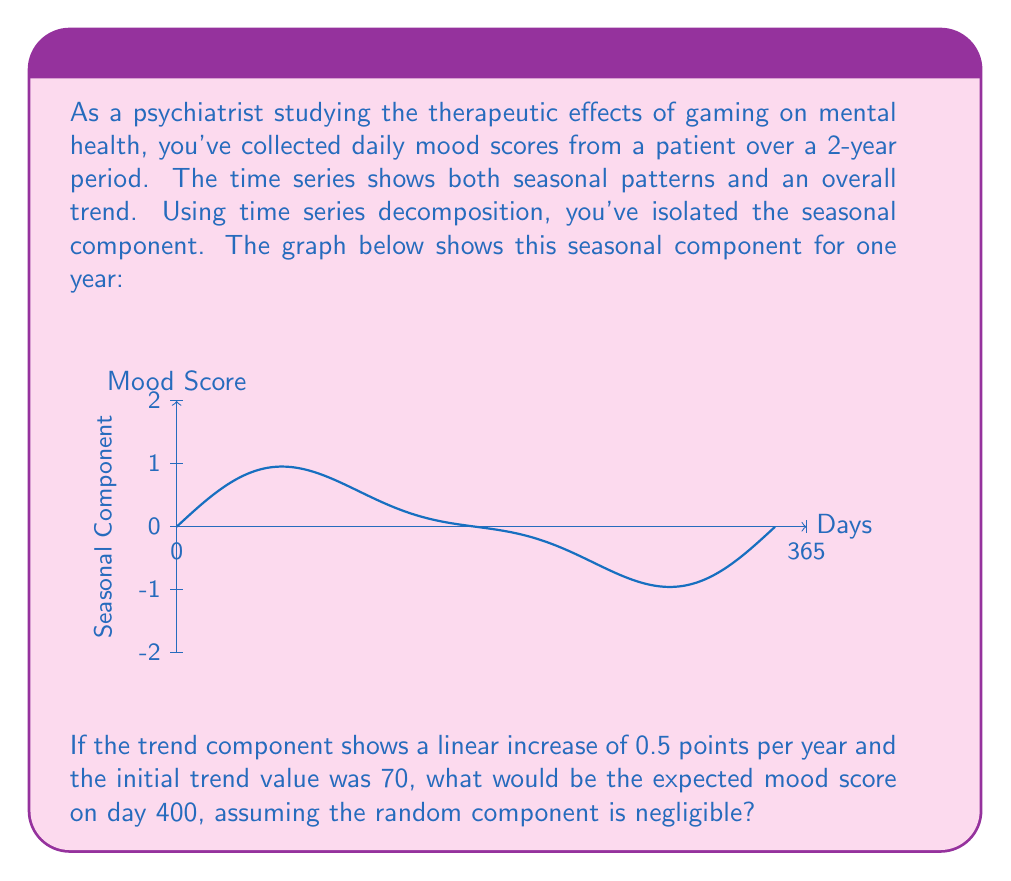Provide a solution to this math problem. To solve this problem, we need to combine the trend and seasonal components for day 400. Let's break it down step-by-step:

1) Trend Component:
   - Initial trend value: 70
   - Increase per year: 0.5 points
   - Time elapsed: 400 days = 400/365 years ≈ 1.0959 years
   - Trend increase: 0.5 * 1.0959 = 0.54795
   - Trend value at day 400: 70 + 0.54795 = 70.54795

2) Seasonal Component:
   - The seasonal pattern repeats every 365 days
   - Day 400 corresponds to day 35 in the seasonal cycle (400 % 365 = 35)
   - From the graph, we can approximate the seasonal component for day 35
   - It appears to be close to 2.5

3) Combining Components:
   - Total score = Trend + Seasonal + Random
   - Random component is negligible (given in the question)
   - Total score = 70.54795 + 2.5 = 73.04795

Therefore, the expected mood score on day 400 is approximately 73.05.
Answer: 73.05 